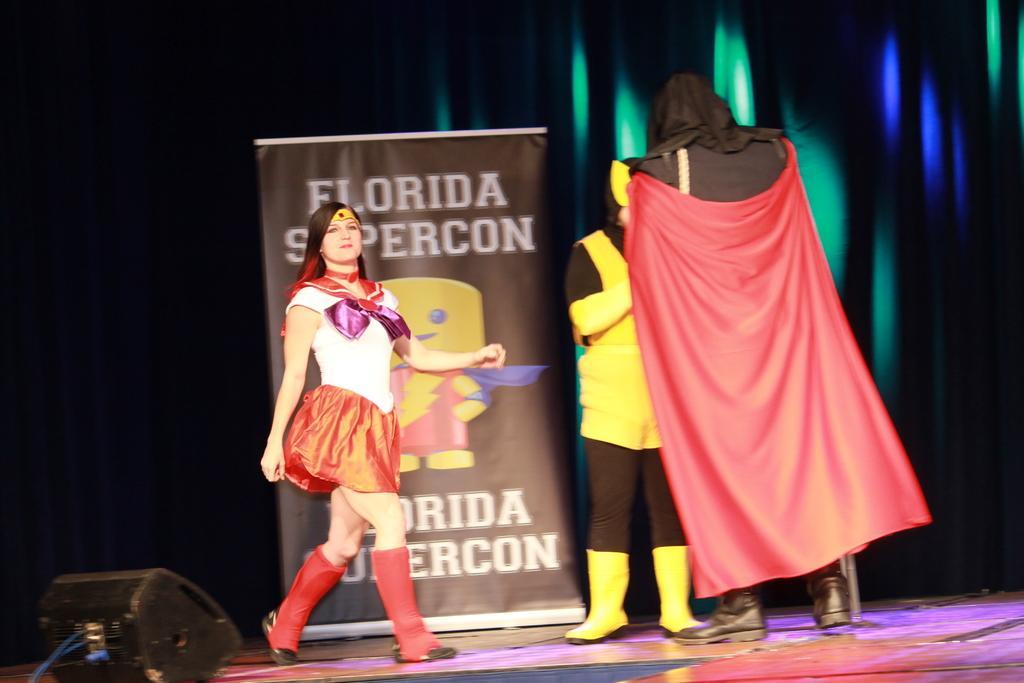Could you give a brief overview of what you see in this image? There are three persons on the stand and wore fancy dresses where on the left a woman is walking on the stage and the other two persons are standing. In the background there is a hoarding and light rays falling on a cloth. On the left at the bottom corner there is a light box. 